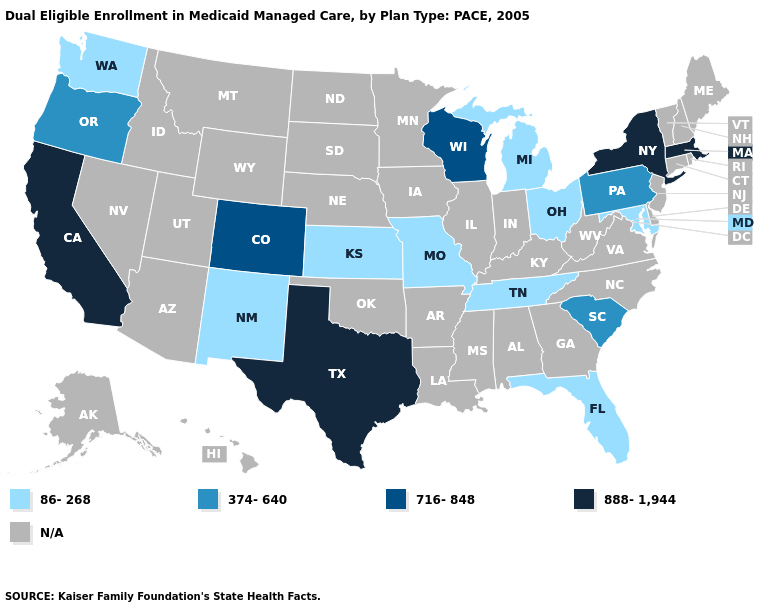What is the lowest value in the MidWest?
Give a very brief answer. 86-268. Among the states that border Illinois , does Missouri have the highest value?
Give a very brief answer. No. Among the states that border Colorado , which have the highest value?
Write a very short answer. Kansas, New Mexico. What is the value of Oregon?
Quick response, please. 374-640. Among the states that border Nevada , does California have the lowest value?
Quick response, please. No. Does Kansas have the lowest value in the USA?
Be succinct. Yes. What is the lowest value in states that border New York?
Write a very short answer. 374-640. Which states have the highest value in the USA?
Be succinct. California, Massachusetts, New York, Texas. Name the states that have a value in the range 888-1,944?
Quick response, please. California, Massachusetts, New York, Texas. Name the states that have a value in the range 716-848?
Short answer required. Colorado, Wisconsin. Does Pennsylvania have the highest value in the Northeast?
Keep it brief. No. What is the lowest value in states that border New York?
Keep it brief. 374-640. 